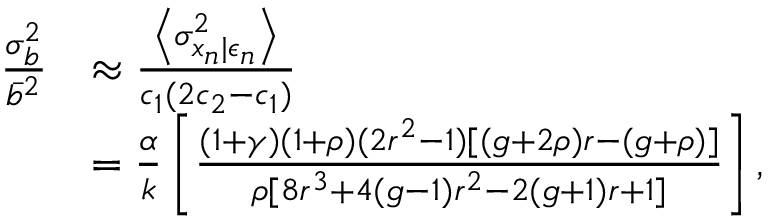<formula> <loc_0><loc_0><loc_500><loc_500>\begin{array} { r l } { \frac { \sigma _ { b } ^ { 2 } } { \bar { b } ^ { 2 } } } & { \approx \frac { \left \langle \sigma _ { x _ { n } | \epsilon _ { n } } ^ { 2 } \right \rangle } { c _ { 1 } ( 2 c _ { 2 } - c _ { 1 } ) } } \\ & { = \frac { \alpha } { k } \left [ \frac { ( 1 + \gamma ) ( 1 + \rho ) ( 2 r ^ { 2 } - 1 ) [ ( g + 2 \rho ) r - ( g + \rho ) ] } { \rho [ 8 r ^ { 3 } + 4 ( g - 1 ) r ^ { 2 } - 2 ( g + 1 ) r + 1 ] } \right ] , } \end{array}</formula> 